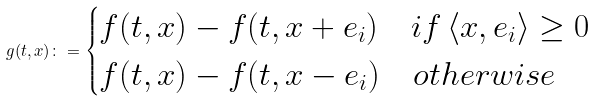<formula> <loc_0><loc_0><loc_500><loc_500>g ( t , x ) \colon = \begin{cases} f ( t , x ) - f ( t , x + e _ { i } ) \quad i f \, \langle x , e _ { i } \rangle \geq 0 \\ f ( t , x ) - f ( t , x - e _ { i } ) \quad o t h e r w i s e \end{cases}</formula> 